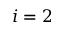Convert formula to latex. <formula><loc_0><loc_0><loc_500><loc_500>i = 2</formula> 